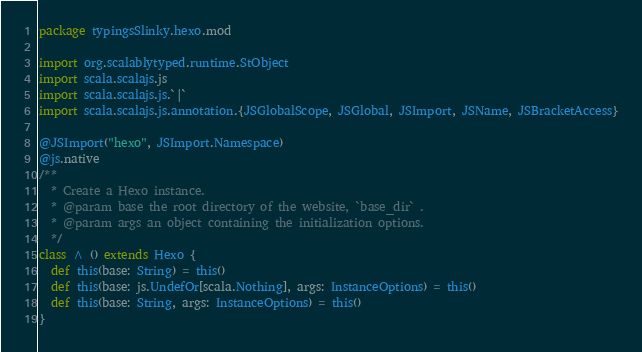<code> <loc_0><loc_0><loc_500><loc_500><_Scala_>package typingsSlinky.hexo.mod

import org.scalablytyped.runtime.StObject
import scala.scalajs.js
import scala.scalajs.js.`|`
import scala.scalajs.js.annotation.{JSGlobalScope, JSGlobal, JSImport, JSName, JSBracketAccess}

@JSImport("hexo", JSImport.Namespace)
@js.native
/**
  * Create a Hexo instance.
  * @param base the root directory of the website, `base_dir` .
  * @param args an object containing the initialization options.
  */
class ^ () extends Hexo {
  def this(base: String) = this()
  def this(base: js.UndefOr[scala.Nothing], args: InstanceOptions) = this()
  def this(base: String, args: InstanceOptions) = this()
}
</code> 